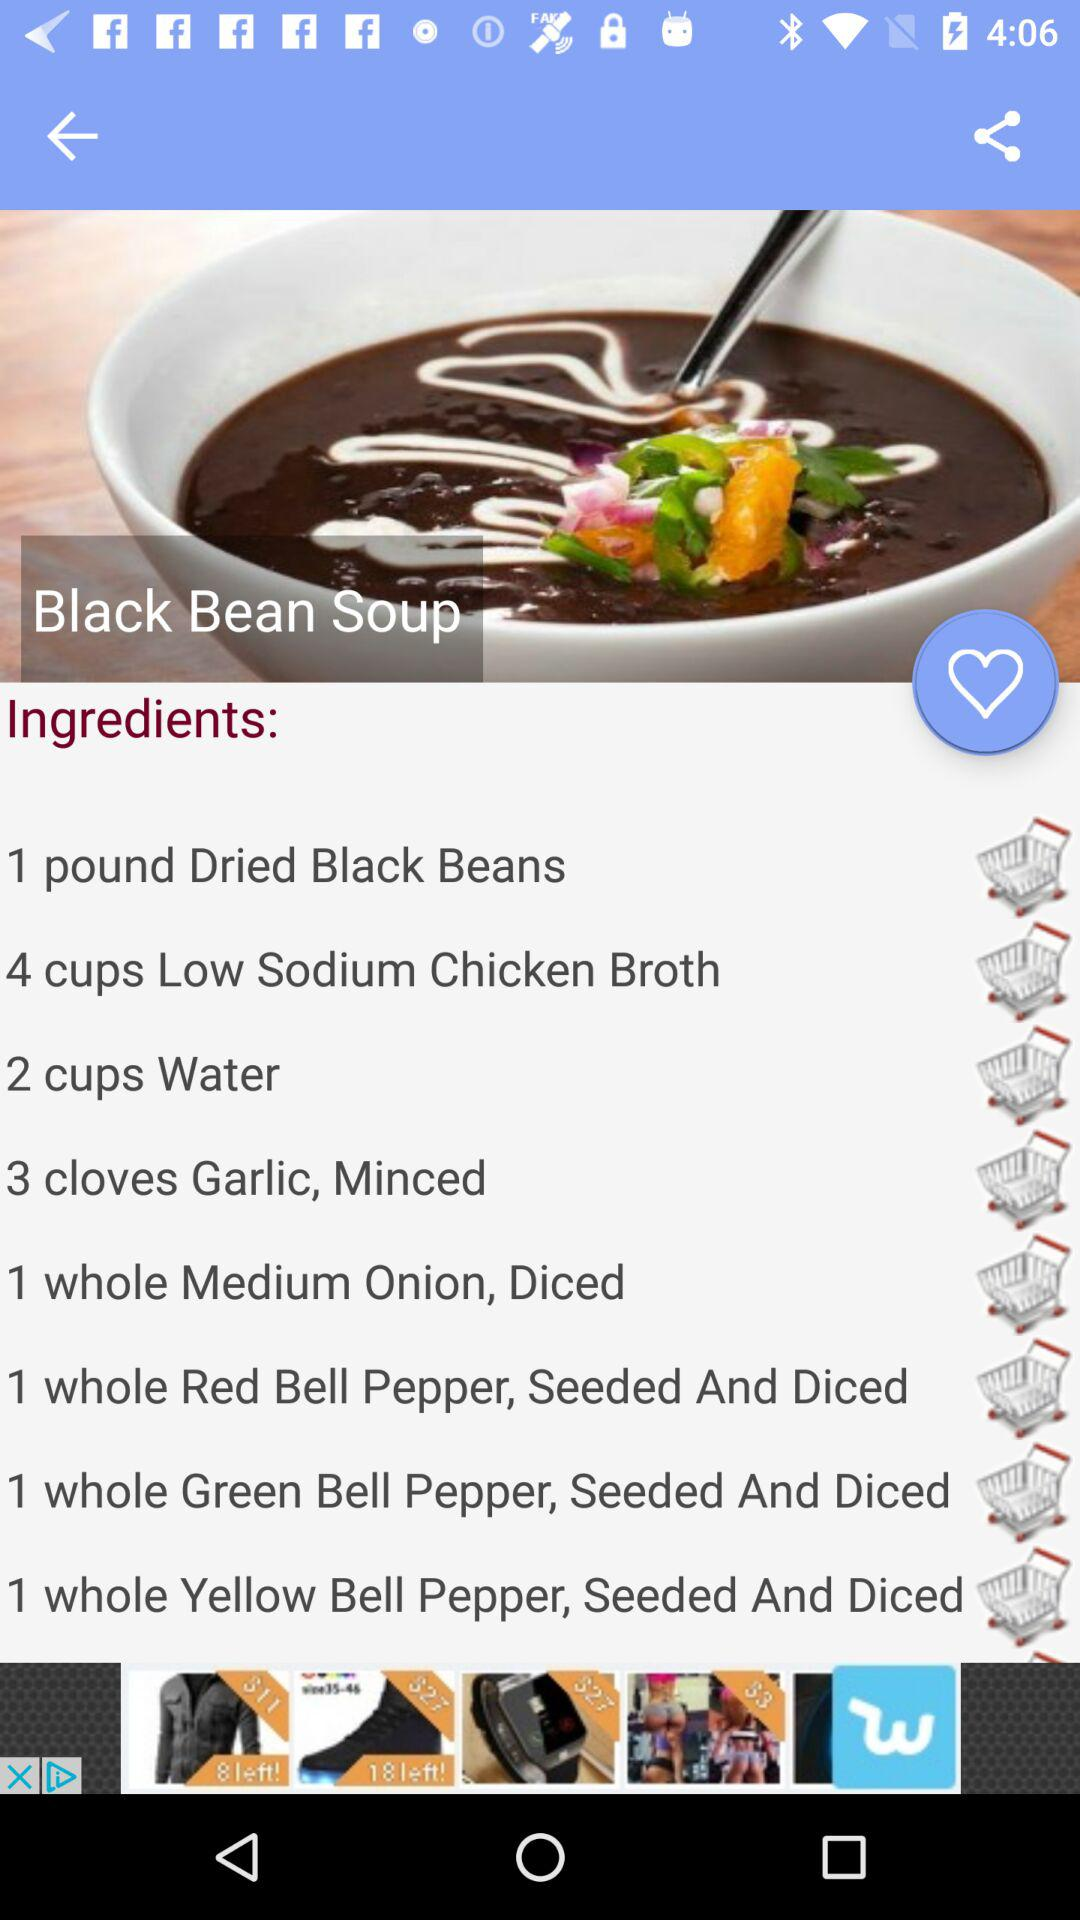How many cups of water are needed? A total of 2 cups of water are needed. 